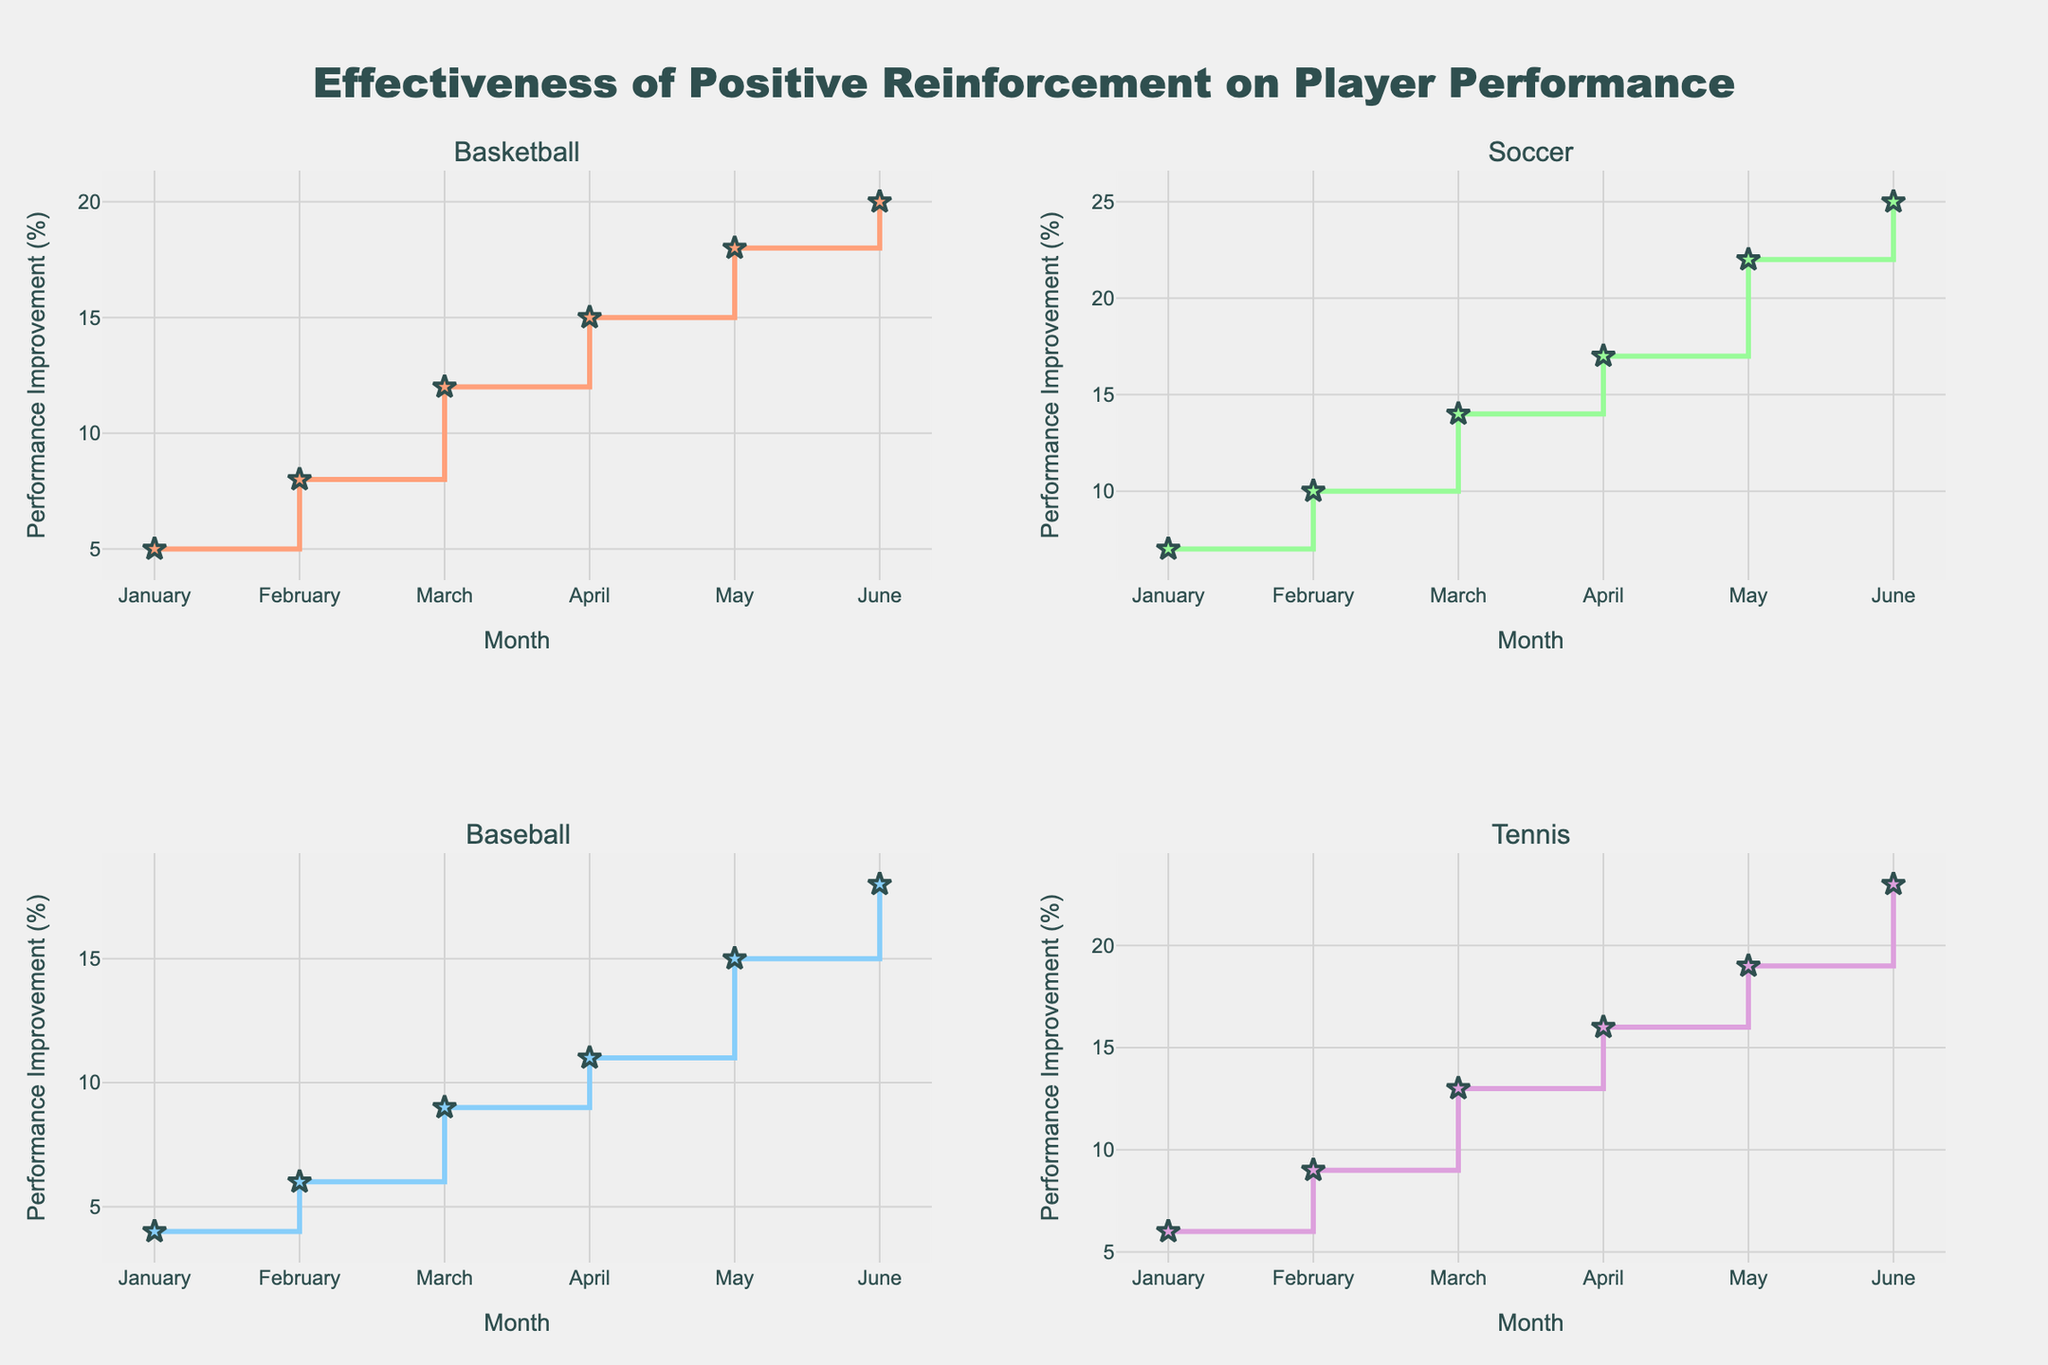What's the title of the figure? The title is written at the top center of the figure.
Answer: Effectiveness of Positive Reinforcement on Player Performance What does the Y-axis represent? The Y-axis label specifies the metric measured in the plot.
Answer: Performance Improvement (%) Which sport shows the highest performance improvement in June? To find this, locate the data point for June on each subplot and compare their Y-axis values. Soccer has a 25% improvement in June, which is the highest.
Answer: Soccer Which month shows the highest performance improvement for Tennis? Look at the Tennis subplot and identify the highest Y-axis value, which is in June with 23%.
Answer: June What is the difference in performance improvement between Basketball and Baseball in April? Find the performance improvement for both Basketball (15%) and Baseball (11%) in April, then subtract the Baseball value from the Basketball value: 15% - 11% = 4%.
Answer: 4% What's the average performance improvement in May across all sports? Add the performance improvement percentages in May for all sports and divide by the number of sports. (Basketball 18 + Soccer 22 + Baseball 15 + Tennis 19) / 4 = 18.5%.
Answer: 18.5% Between which two consecutive months does Soccer show the largest increase in performance improvement? Look at the Soccer subplot and calculate the difference in performance improvement between consecutive months. The largest jump is between April (17%) and May (22%), which is a 5% increase.
Answer: April to May How does Tennis' improvement in March compare to Basketball's improvement in the same month? Find the performance improvement percentage for both sports in March. Tennis has 13%, and Basketball has 12%. Tennis' improvement is 1% higher.
Answer: 1% higher Is there any month where Basketball's improvement is greater than Soccer's? Compare the performance improvements for Basketball and Soccer for each month. There is no month where Basketball's improvement exceeds Soccer's.
Answer: No What's the total performance improvement for Baseball from January to June? Add the performance improvements for Baseball from January to June: 4 + 6 + 9 + 11 + 15 + 18 = 63%.
Answer: 63% 